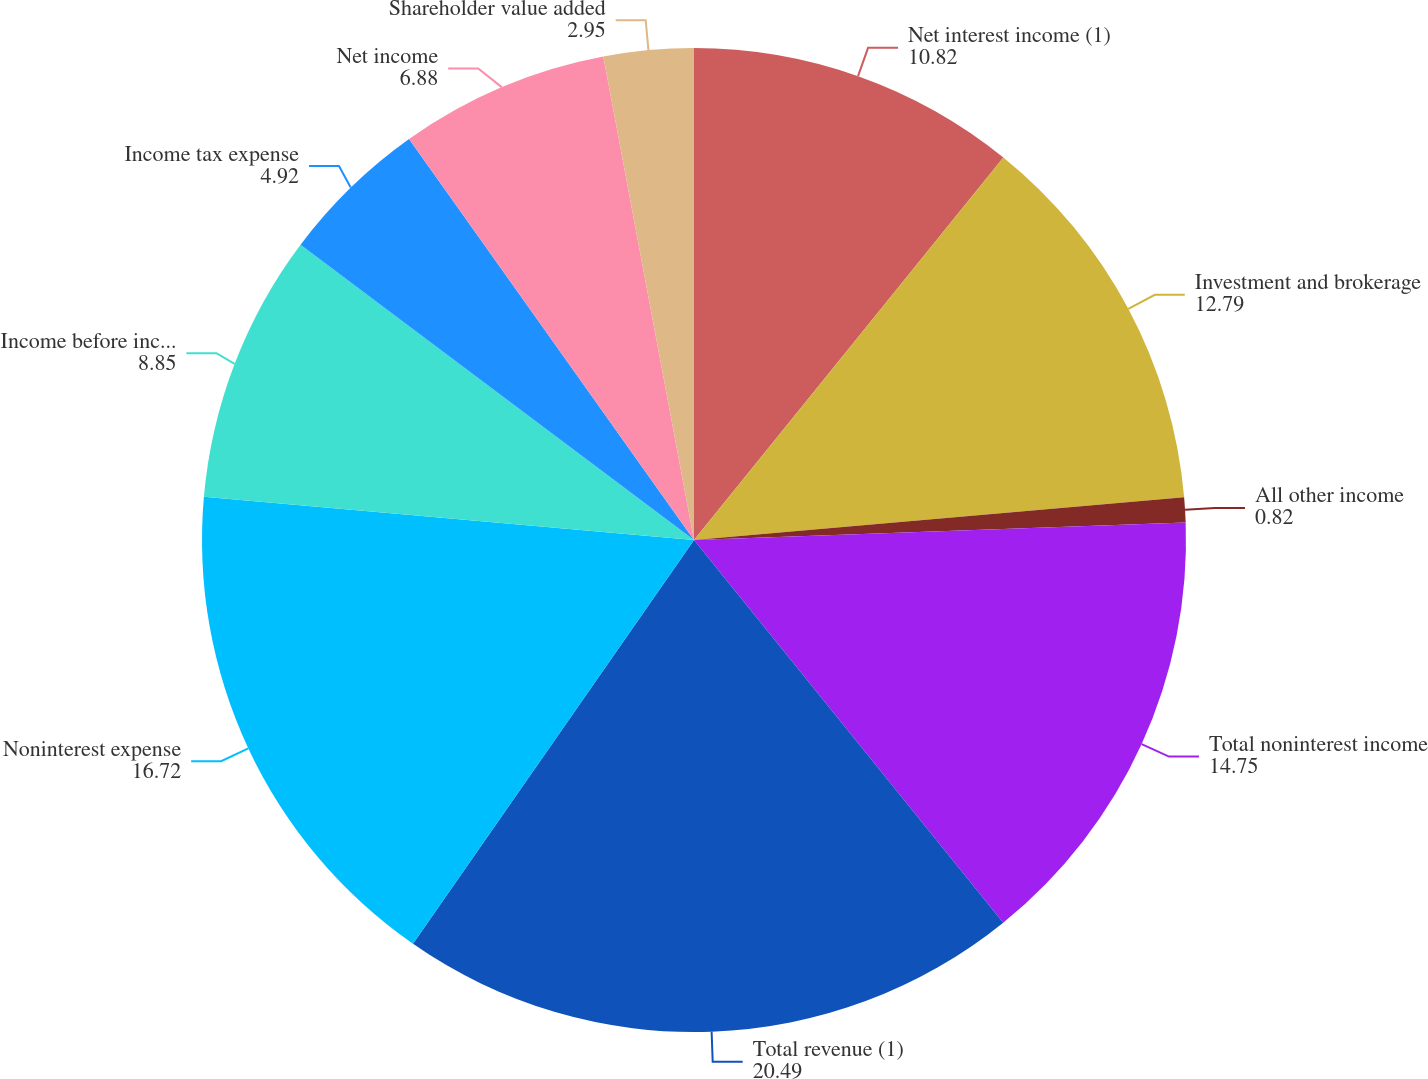Convert chart to OTSL. <chart><loc_0><loc_0><loc_500><loc_500><pie_chart><fcel>Net interest income (1)<fcel>Investment and brokerage<fcel>All other income<fcel>Total noninterest income<fcel>Total revenue (1)<fcel>Noninterest expense<fcel>Income before income taxes (1)<fcel>Income tax expense<fcel>Net income<fcel>Shareholder value added<nl><fcel>10.82%<fcel>12.79%<fcel>0.82%<fcel>14.75%<fcel>20.49%<fcel>16.72%<fcel>8.85%<fcel>4.92%<fcel>6.88%<fcel>2.95%<nl></chart> 